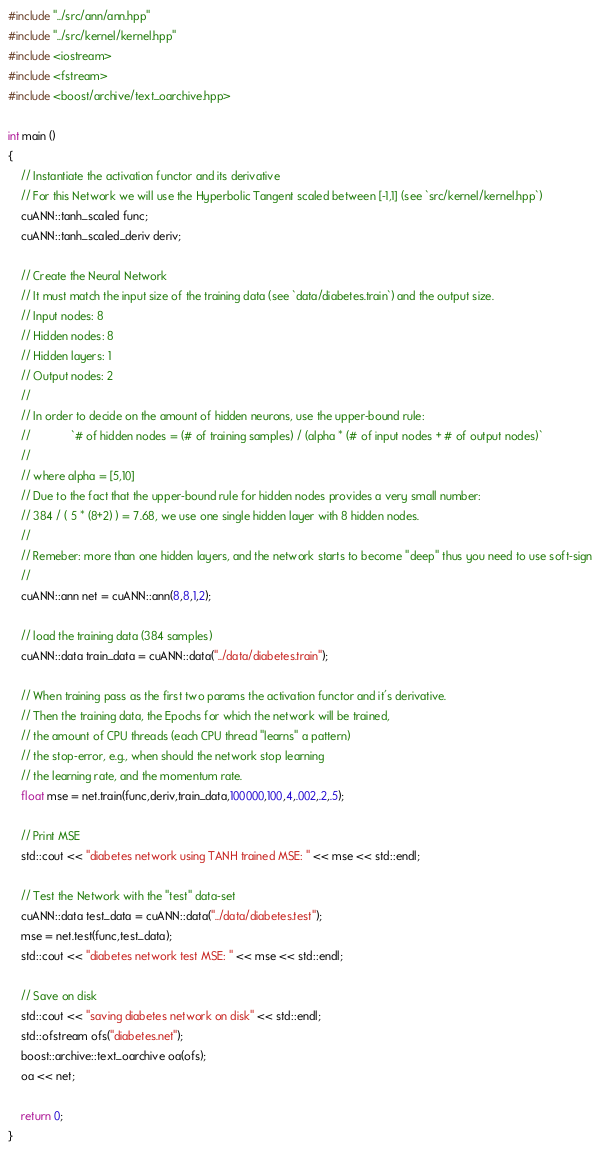Convert code to text. <code><loc_0><loc_0><loc_500><loc_500><_Cuda_>#include "../src/ann/ann.hpp"
#include "../src/kernel/kernel.hpp"
#include <iostream>
#include <fstream>
#include <boost/archive/text_oarchive.hpp>

int main ()
{
    // Instantiate the activation functor and its derivative
    // For this Network we will use the Hyperbolic Tangent scaled between [-1,1] (see `src/kernel/kernel.hpp`)
    cuANN::tanh_scaled func;
    cuANN::tanh_scaled_deriv deriv;

    // Create the Neural Network
    // It must match the input size of the training data (see `data/diabetes.train`) and the output size.
    // Input nodes: 8
    // Hidden nodes: 8
    // Hidden layers: 1
    // Output nodes: 2
    //
    // In order to decide on the amount of hidden neurons, use the upper-bound rule:
    //             `# of hidden nodes = (# of training samples) / (alpha * (# of input nodes + # of output nodes)`
    //
    // where alpha = [5,10]
    // Due to the fact that the upper-bound rule for hidden nodes provides a very small number:
    // 384 / ( 5 * (8+2) ) = 7.68, we use one single hidden layer with 8 hidden nodes.
    //
    // Remeber: more than one hidden layers, and the network starts to become "deep" thus you need to use soft-sign
    //
    cuANN::ann net = cuANN::ann(8,8,1,2);

    // load the training data (384 samples)
    cuANN::data train_data = cuANN::data("../data/diabetes.train");

    // When training pass as the first two params the activation functor and it's derivative.
    // Then the training data, the Epochs for which the network will be trained,
    // the amount of CPU threads (each CPU thread "learns" a pattern)
    // the stop-error, e.g., when should the network stop learning
    // the learning rate, and the momentum rate.
    float mse = net.train(func,deriv,train_data,100000,100,4,.002,.2,.5);

    // Print MSE
    std::cout << "diabetes network using TANH trained MSE: " << mse << std::endl;

    // Test the Network with the "test" data-set
    cuANN::data test_data = cuANN::data("../data/diabetes.test");
    mse = net.test(func,test_data);
    std::cout << "diabetes network test MSE: " << mse << std::endl;
   
    // Save on disk
    std::cout << "saving diabetes network on disk" << std::endl;
    std::ofstream ofs("diabetes.net");
    boost::archive::text_oarchive oa(ofs);
    oa << net;
    
    return 0;
}
</code> 